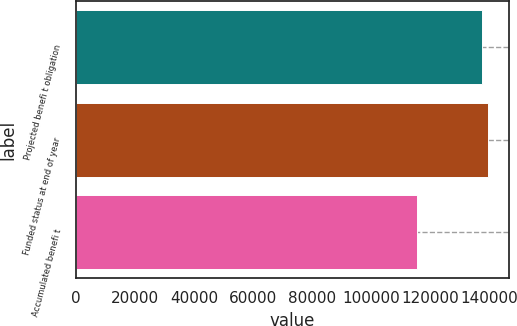Convert chart to OTSL. <chart><loc_0><loc_0><loc_500><loc_500><bar_chart><fcel>Projected benefi t obligation<fcel>Funded status at end of year<fcel>Accumulated benefi t<nl><fcel>137271<fcel>139470<fcel>115286<nl></chart> 